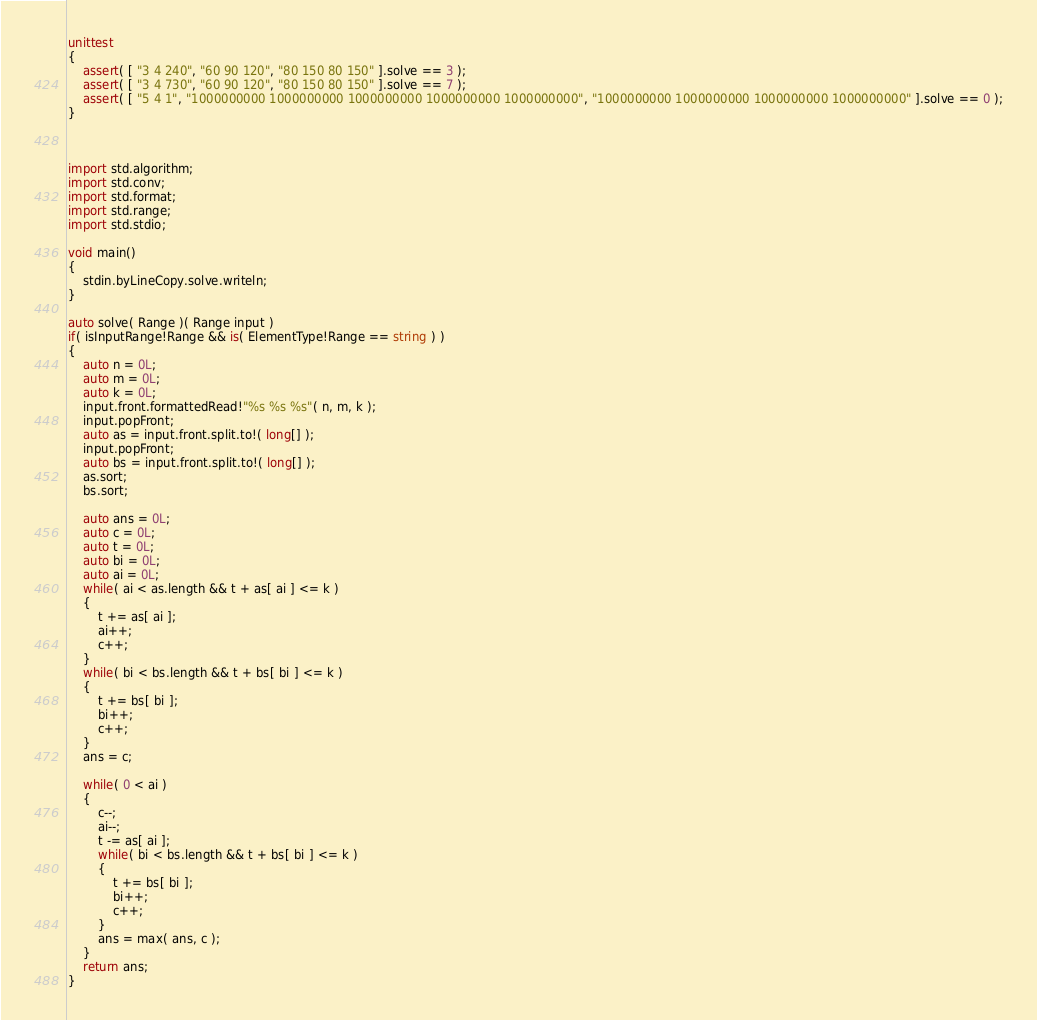<code> <loc_0><loc_0><loc_500><loc_500><_D_>unittest
{
	assert( [ "3 4 240", "60 90 120", "80 150 80 150" ].solve == 3 );
	assert( [ "3 4 730", "60 90 120", "80 150 80 150" ].solve == 7 );
	assert( [ "5 4 1", "1000000000 1000000000 1000000000 1000000000 1000000000", "1000000000 1000000000 1000000000 1000000000" ].solve == 0 );
}



import std.algorithm;
import std.conv;
import std.format;
import std.range;
import std.stdio;

void main()
{
	stdin.byLineCopy.solve.writeln;
}

auto solve( Range )( Range input )
if( isInputRange!Range && is( ElementType!Range == string ) )
{
	auto n = 0L;
	auto m = 0L;
	auto k = 0L;
	input.front.formattedRead!"%s %s %s"( n, m, k );
	input.popFront;
	auto as = input.front.split.to!( long[] );
	input.popFront;
	auto bs = input.front.split.to!( long[] );
	as.sort;
	bs.sort;
	
	auto ans = 0L;
	auto c = 0L;
	auto t = 0L;
	auto bi = 0L;
	auto ai = 0L;
	while( ai < as.length && t + as[ ai ] <= k )
	{
		t += as[ ai ];
		ai++;
		c++;
	}
	while( bi < bs.length && t + bs[ bi ] <= k )
	{
		t += bs[ bi ];
		bi++;
		c++;
	}
	ans = c;
	
	while( 0 < ai )
	{
		c--;
		ai--;
		t -= as[ ai ];
		while( bi < bs.length && t + bs[ bi ] <= k )
		{
			t += bs[ bi ];
			bi++;
			c++;
		}
		ans = max( ans, c );
	}
	return ans;
}
</code> 